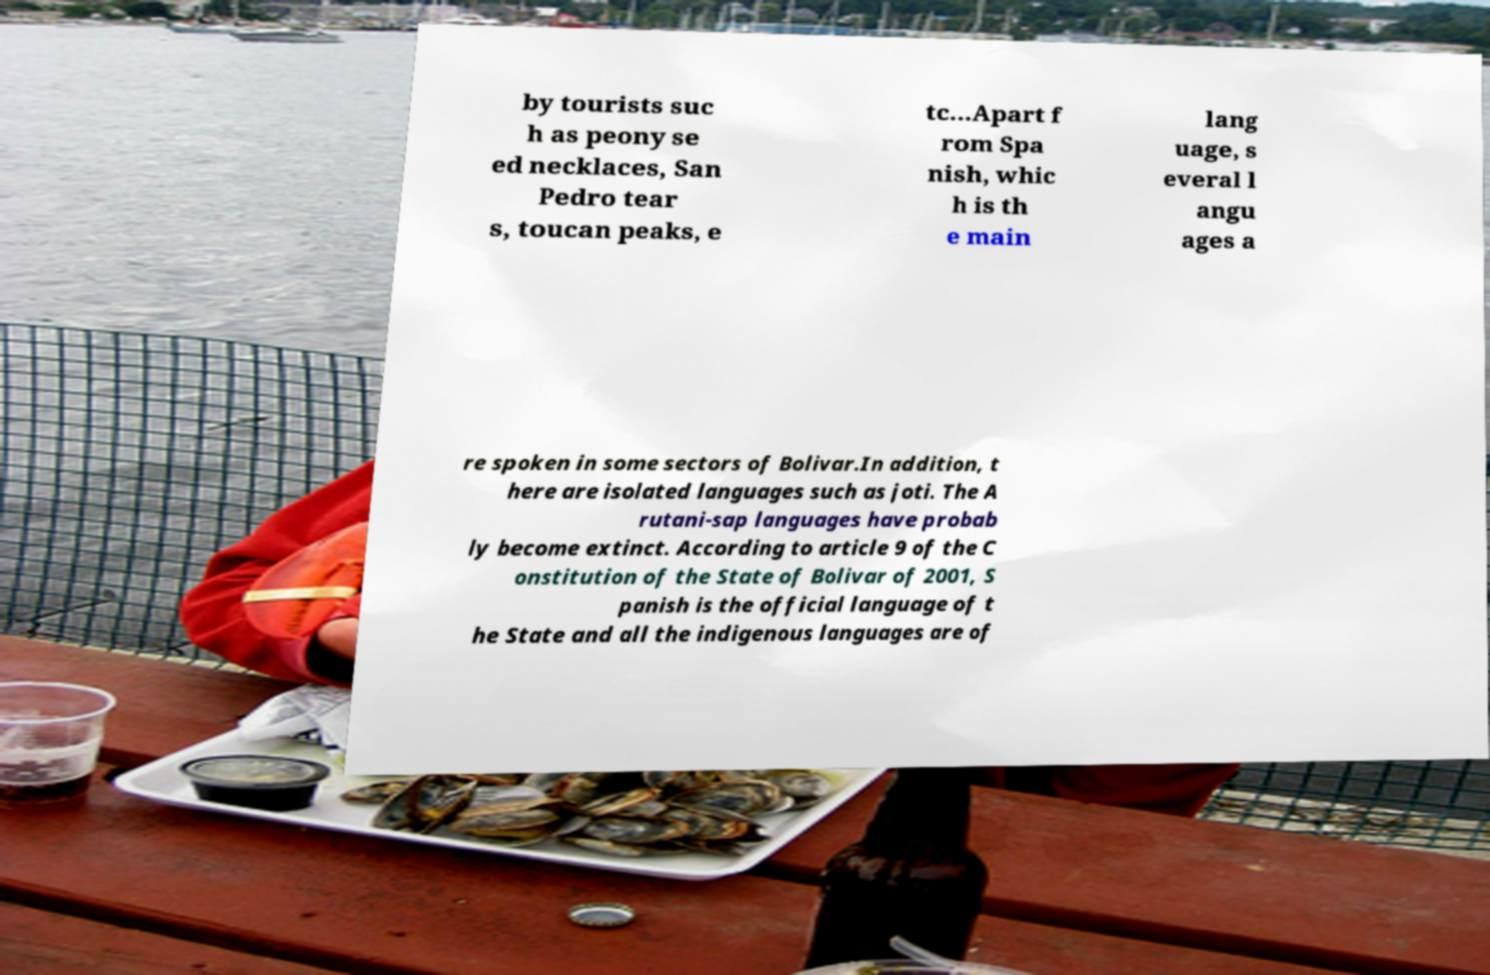I need the written content from this picture converted into text. Can you do that? by tourists suc h as peony se ed necklaces, San Pedro tear s, toucan peaks, e tc...Apart f rom Spa nish, whic h is th e main lang uage, s everal l angu ages a re spoken in some sectors of Bolivar.In addition, t here are isolated languages such as joti. The A rutani-sap languages have probab ly become extinct. According to article 9 of the C onstitution of the State of Bolivar of 2001, S panish is the official language of t he State and all the indigenous languages are of 